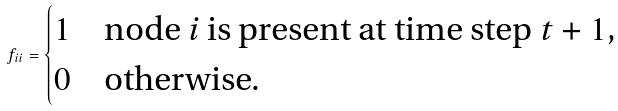<formula> <loc_0><loc_0><loc_500><loc_500>f _ { i i } = \begin{cases} 1 & \text {node $i$ is present at time step $t+1$,} \\ 0 & \text {otherwise.} \end{cases}</formula> 